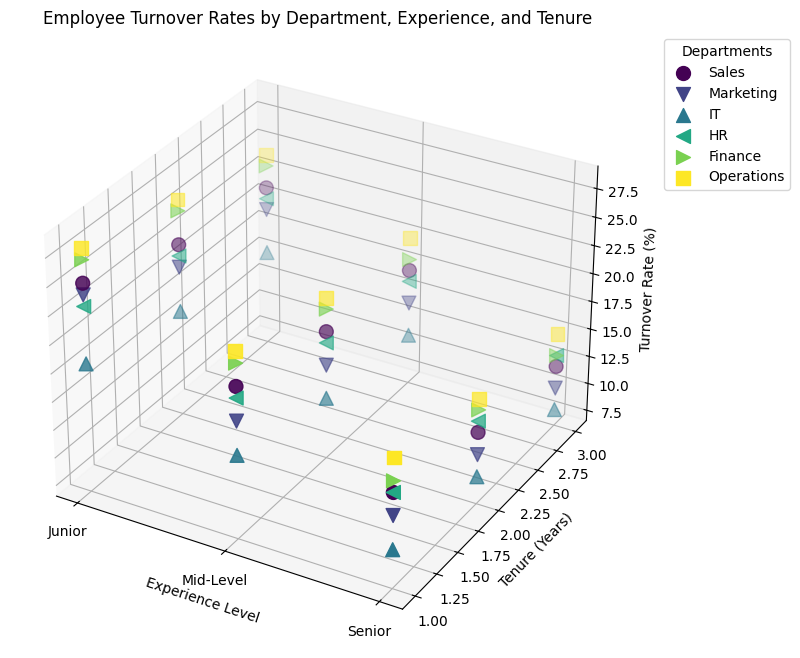Which department has the highest turnover rate for Junior employees with 1-year tenure? Look at the points representing Junior employees with 1-year tenure and compare their turnover rates based on the height in the z-axis. The highest point corresponds to the highest turnover rate. According to the plot, the 'Operations' department has the highest turnover rate for Junior employees with 1-year tenure.
Answer: Operations How does the turnover rate of Senior employees with 3 years of tenure compare between the IT and HR departments? Visualize the points representing Senior employees with 3 years of tenure in both the IT and HR departments and compare their heights on the z-axis. The turnover rate in IT is lower than in HR.
Answer: Lower in IT What's the difference in turnover rate between Mid-Level employees with 1-year tenure in the Sales and Finance departments? Identify the points for Mid-Level employees with 1-year tenure in both Sales and Finance and calculate the difference in their turnover rates by subtracting the lower rate from the higher rate. The turnover rates are 20% for Sales and 22% for Finance, so the difference is 2%.
Answer: 2% What's the average turnover rate for Mid-Level employees across all departments with 2 years of tenure? Locate and sum the turnover rates for Mid-Level employees with 2 years of tenure from all departments, then divide by the number of departments. The turnover rates are 18% (Sales), 15% (Marketing), 12% (IT), 17% (HR), 20% (Finance), and 21% (Operations). Calculate (18 + 15 + 12 + 17 + 20 + 21) / 6 = 103 / 6 ≈ 17.17%.
Answer: 17.17% Which department shows the smallest reduction in turnover rate from Junior to Senior level for employees with 3 years of tenure? Compare the reduction in turnover rates for departments by subtracting the turnover rate of Senior employees from Junior employees, both with 3 years of tenure. The smallest reduction indicates minimum improvement. The reductions are (21-12) for Sales, (19-10) for Marketing, (15-8) for IT, (20-13) for HR, (23-13) for Finance, and (24-15) for Operations. The smallest reduction is for IT, a reduction of 7%.
Answer: IT How does the visual representation of the turnover rate for Sales compare to the rest of the departments? Visually inspect the Sales department points for trends in height (turnover rate) and color representation (department) across the axes, noting how they stack up against other departments. Sales appears to have a relatively consistent turnover rate reduction as experience and tenure increase compared to others.
Answer: Consistent reduction Which Senior employees with 1-year tenure have the lowest turnover rate, and in which department? Look for the lowest points (indicating turnover rates) among Senior employees with 1-year tenure and identify the department by the color and labels. IT department has the lowest turnover rate for Senior employees with 1-year tenure at 10%.
Answer: IT 